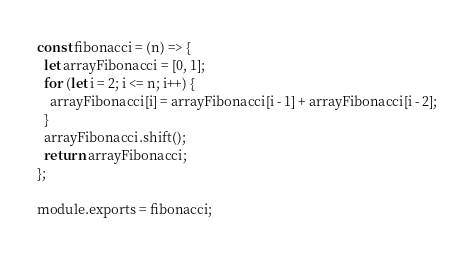<code> <loc_0><loc_0><loc_500><loc_500><_JavaScript_>const fibonacci = (n) => {
  let arrayFibonacci = [0, 1];
  for (let i = 2; i <= n; i++) {
    arrayFibonacci[i] = arrayFibonacci[i - 1] + arrayFibonacci[i - 2];
  }
  arrayFibonacci.shift();
  return arrayFibonacci;
};

module.exports = fibonacci;
</code> 